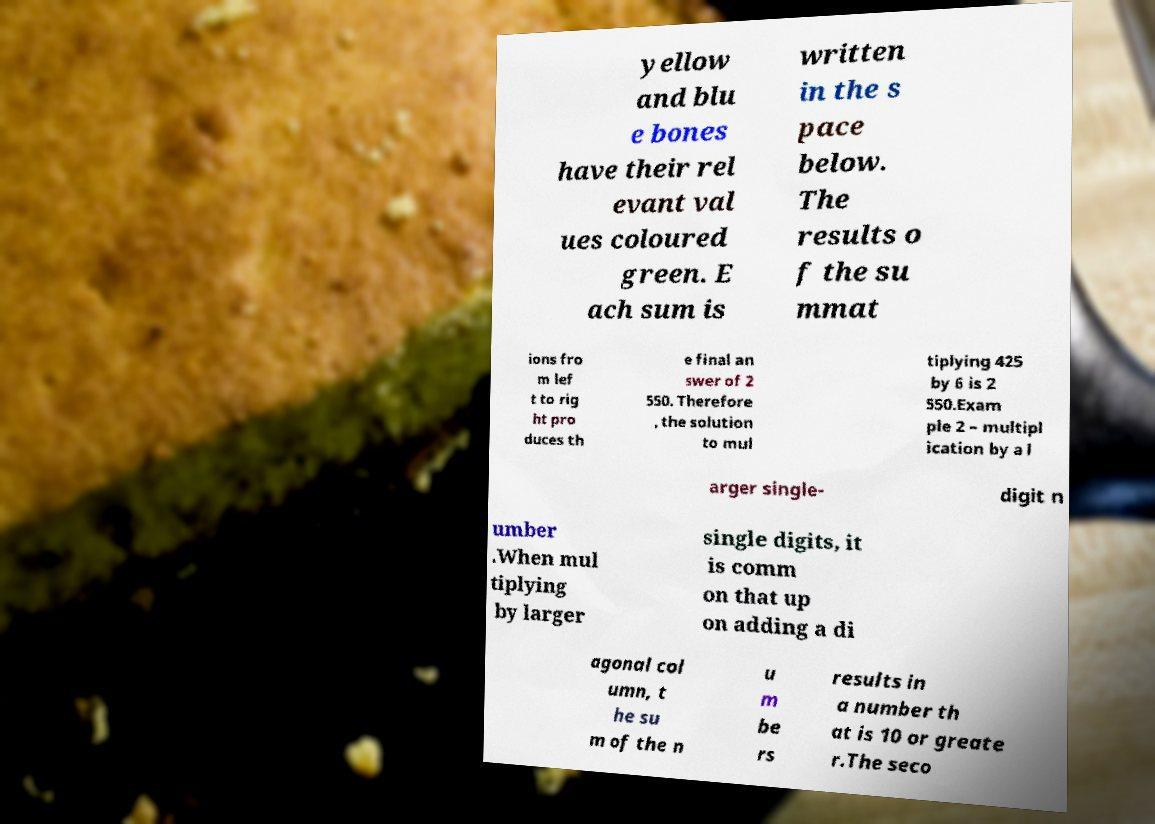For documentation purposes, I need the text within this image transcribed. Could you provide that? yellow and blu e bones have their rel evant val ues coloured green. E ach sum is written in the s pace below. The results o f the su mmat ions fro m lef t to rig ht pro duces th e final an swer of 2 550. Therefore , the solution to mul tiplying 425 by 6 is 2 550.Exam ple 2 – multipl ication by a l arger single- digit n umber .When mul tiplying by larger single digits, it is comm on that up on adding a di agonal col umn, t he su m of the n u m be rs results in a number th at is 10 or greate r.The seco 